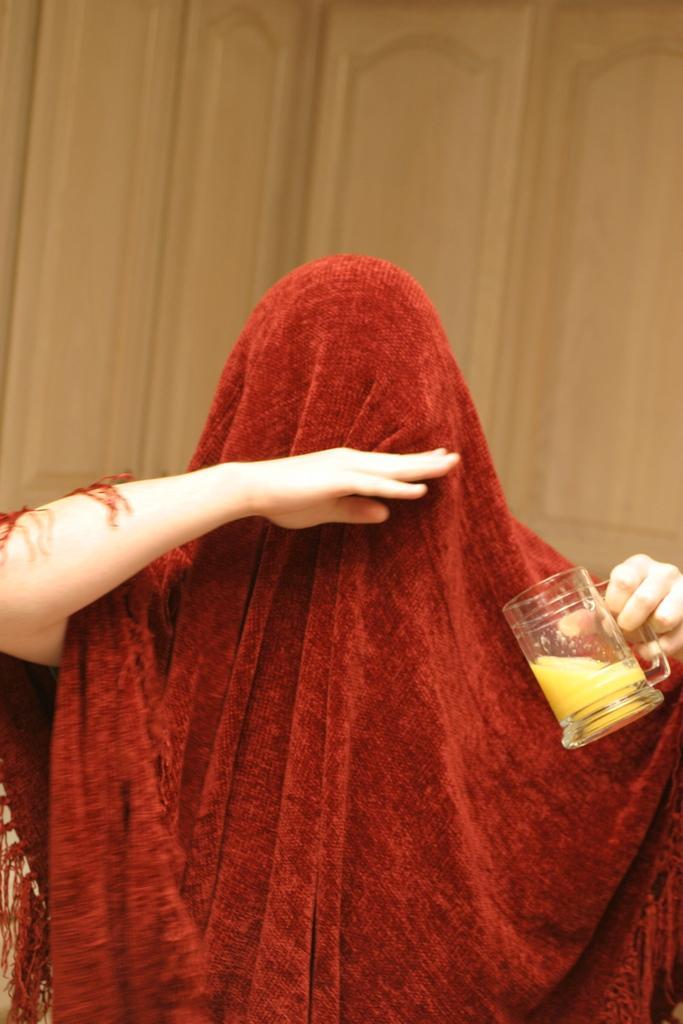Please provide a concise description of this image. In this image there is a person standing with a scarf on him holding a glass. 